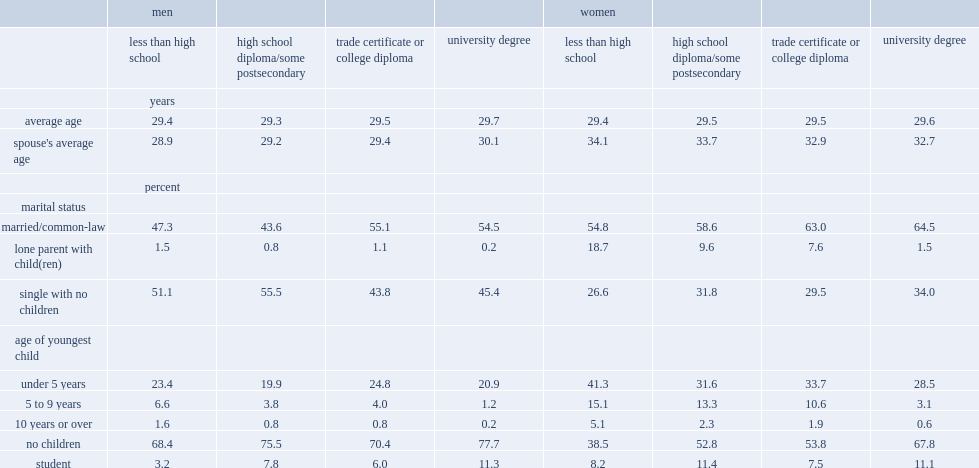Which level of education of men who were married or living common law was lower? those who did not finish high school or those with a trade cetificate, college diploma or university degree? Less than high school. What level ofeducation of female was least likley to be married or in a common-law relationship? Less than high school. What fraction of women aged 25 to 34 without a high school diploma was a lone parent, compared with less than 2% of women with a university degree in 2016? 18.7. Which marital status of men had percentages below 2% regardless of education level? Lone parent with child(ren). What percent of women aged 25 to 34 who did not finish high school has at least one child, compared with 32% for those with a university degree? 61.5. What percent of young men without a high school diploma has at least one child, compared with 22% of young men with a university degree? 31.6. 